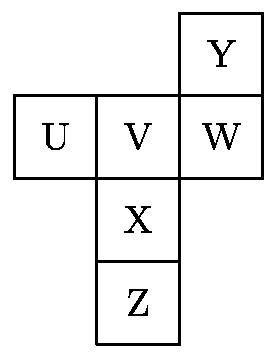What is the relationship between the squares labeled 'U' and 'V' when the paper is folded into a cube? When folded into a cube, the squares labeled 'U' and 'V' will be adjacent to each other, sharing one edge. This arrangement allows them to be side-by-side on the cube. 